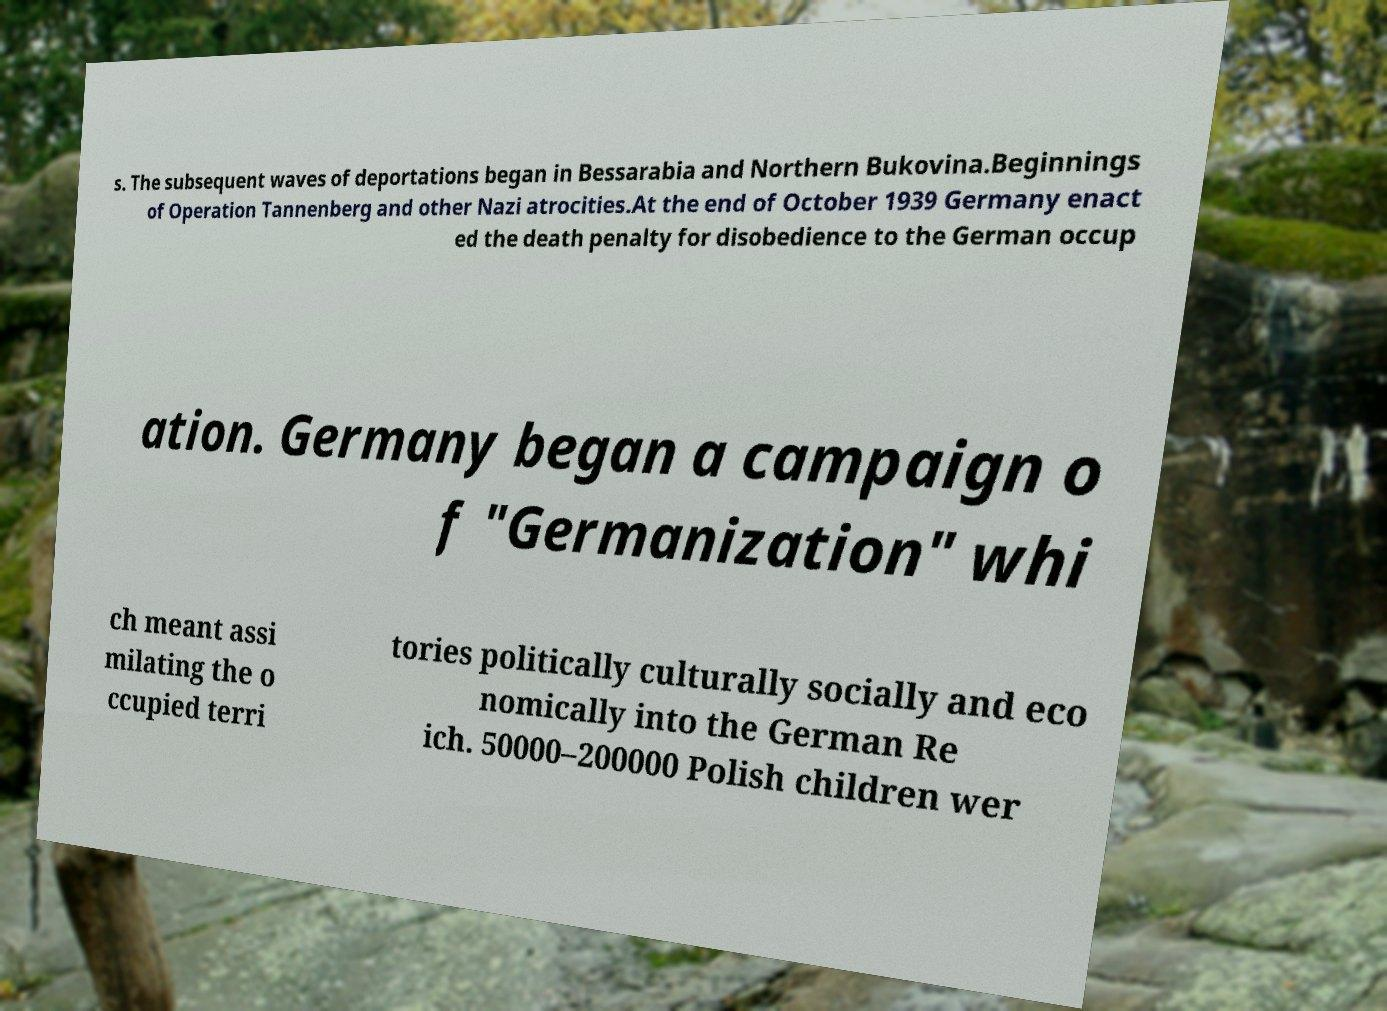What messages or text are displayed in this image? I need them in a readable, typed format. s. The subsequent waves of deportations began in Bessarabia and Northern Bukovina.Beginnings of Operation Tannenberg and other Nazi atrocities.At the end of October 1939 Germany enact ed the death penalty for disobedience to the German occup ation. Germany began a campaign o f "Germanization" whi ch meant assi milating the o ccupied terri tories politically culturally socially and eco nomically into the German Re ich. 50000–200000 Polish children wer 